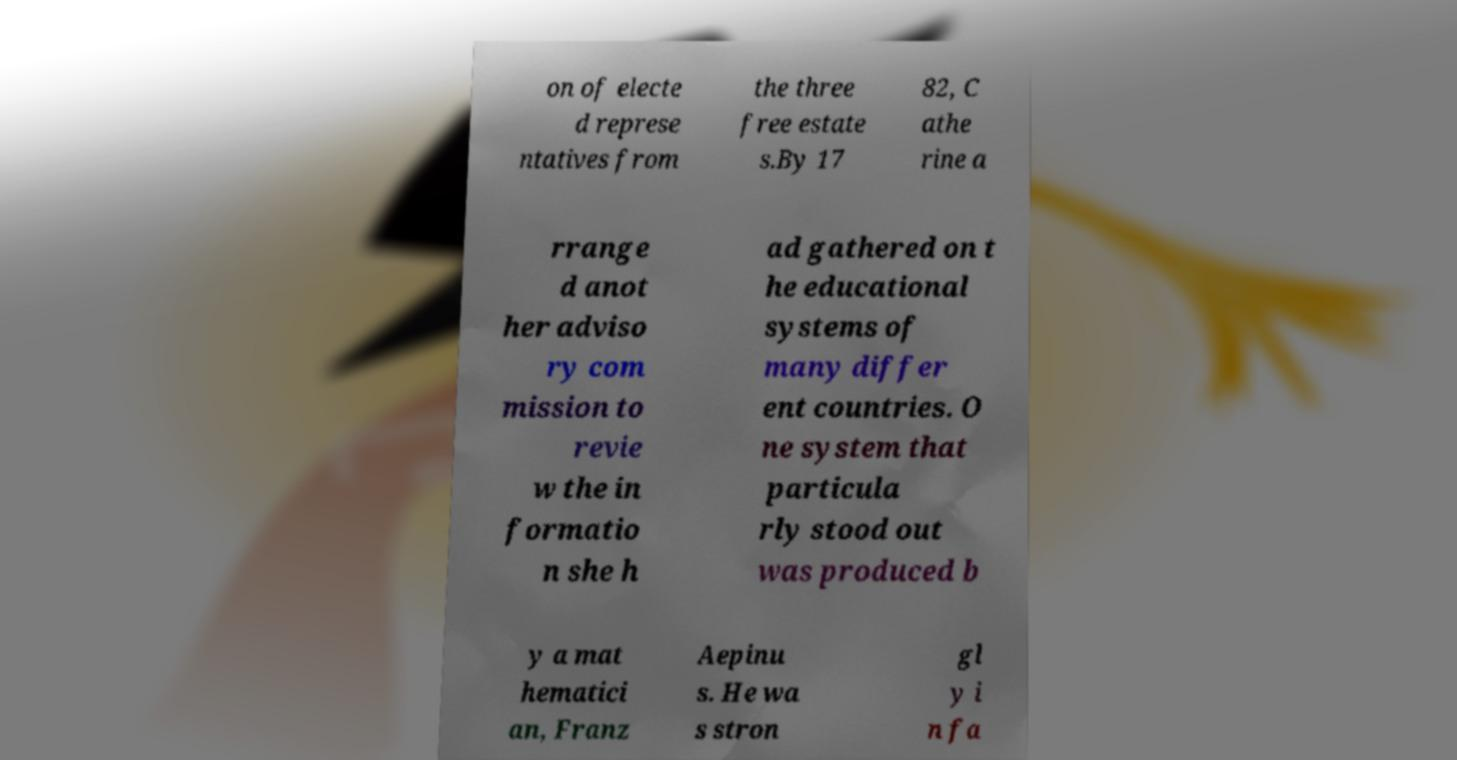There's text embedded in this image that I need extracted. Can you transcribe it verbatim? on of electe d represe ntatives from the three free estate s.By 17 82, C athe rine a rrange d anot her adviso ry com mission to revie w the in formatio n she h ad gathered on t he educational systems of many differ ent countries. O ne system that particula rly stood out was produced b y a mat hematici an, Franz Aepinu s. He wa s stron gl y i n fa 